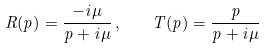<formula> <loc_0><loc_0><loc_500><loc_500>R ( p ) = \frac { - i \mu } { p + i \mu } \, , \quad T ( p ) = \frac { p } { p + i \mu }</formula> 